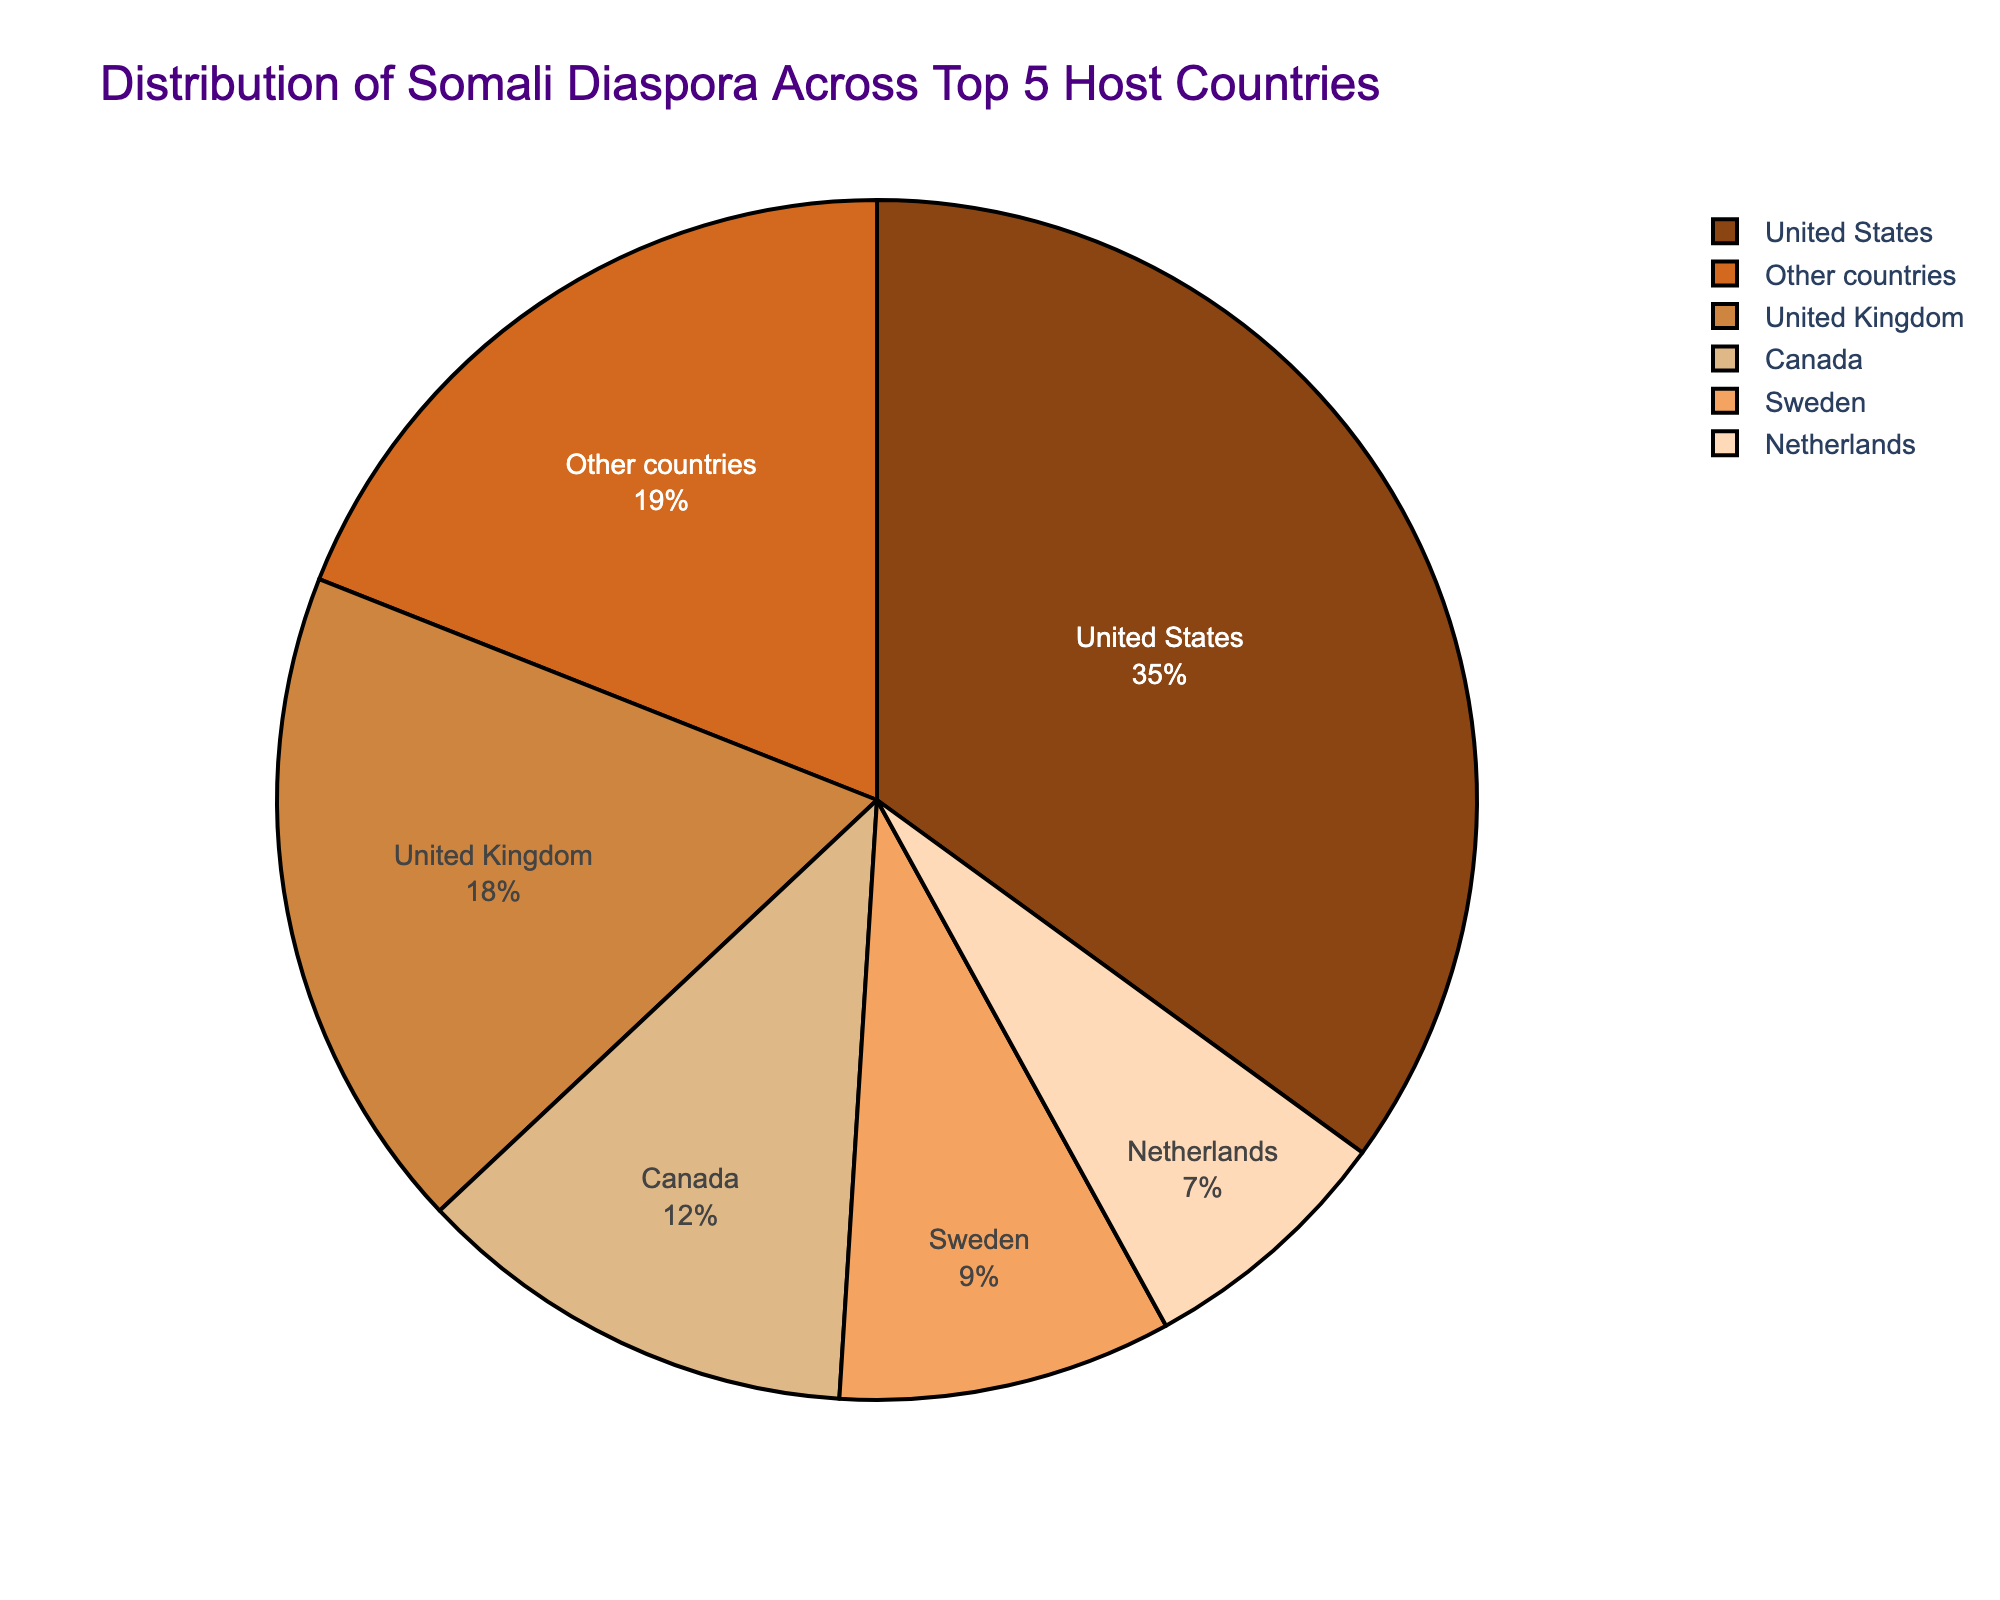What percentage of the Somali diaspora resides in the United States? According to the pie chart, the section labeled "United States" represents 35% of the total Somali diaspora.
Answer: 35% Which country has the second largest Somali diaspora? The pie chart shows that the United Kingdom has the second largest section, labeled with 18%.
Answer: United Kingdom What is the combined percentage of the Somali diaspora residing in Canada and Sweden? The pie chart states 12% for Canada and 9% for Sweden. Adding these together, 12 + 9 = 21%.
Answer: 21% How much larger is the Somali diaspora in the United States compared to the United Kingdom? The United States is at 35% and the United Kingdom is at 18%. The difference is 35 - 18 = 17%.
Answer: 17% Which country hosts a smaller percentage of the Somali diaspora, the Netherlands or Sweden? By visual inspection, Sweden has a larger section labeled 9%, while the Netherlands has a smaller one labeled 7%.
Answer: Netherlands If we combined the percentages of the Somali diaspora in the Netherlands and other countries, would it surpass the percentage in the United States? The Netherlands is 7% and other countries are 19%, combined they are 7 + 19 = 26%, which is less than the 35% in the United States.
Answer: No What color represents Canada on the pie chart? The visual attribute of the section labeled "Canada" is the color '#CD853F'. In natural language, this color can be described as a shade of brown.
Answer: A shade of brown Is the percentage of Somali diaspora in the United Kingdom more than twice that in the Netherlands? The pie chart indicates 18% for the United Kingdom and 7% for the Netherlands. Twice the percentage of the Netherlands would be 7 * 2 = 14%, so the United Kingdom's 18% is indeed more than twice 7%.
Answer: Yes What is the percentage difference between the Somali diaspora in the top three countries combined (USA, UK, Canada) and the remaining countries (Sweden, Netherlands, Other countries)? The top three countries are USA (35%), UK (18%), and Canada (12%), adding to 35 + 18 + 12 = 65%. The remaining countries are Sweden (9%), Netherlands (7%), and Other countries (19%), cumulating to 9 + 7 + 19 = 35%. The difference is 65 - 35 = 30%.
Answer: 30% 